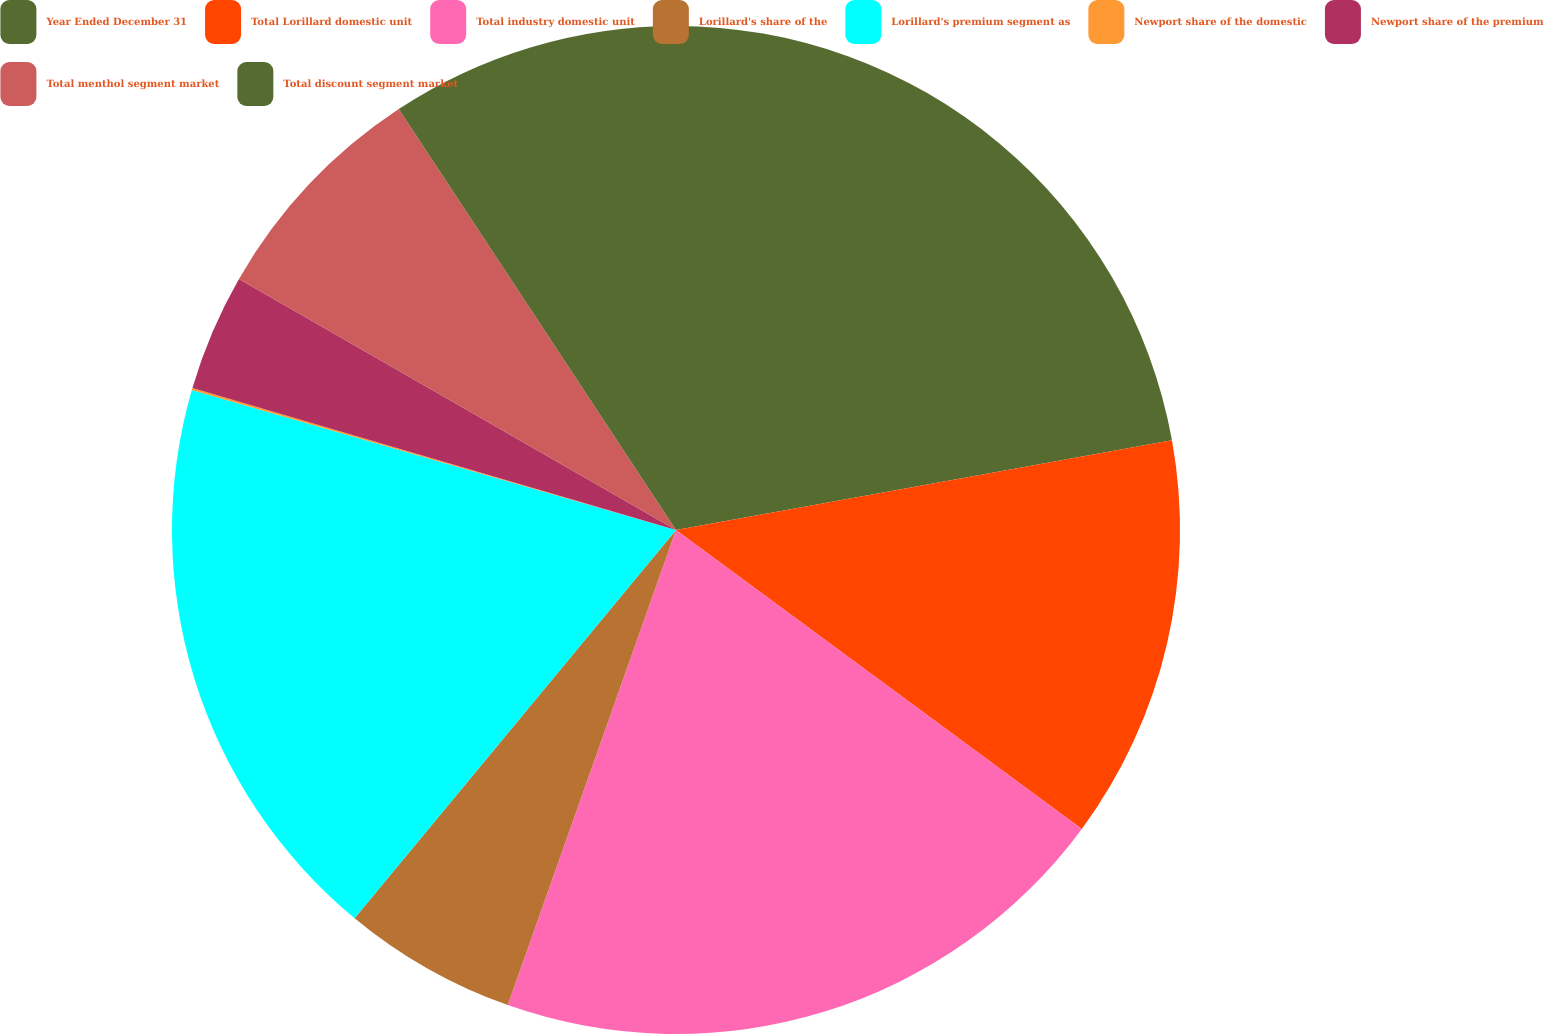<chart> <loc_0><loc_0><loc_500><loc_500><pie_chart><fcel>Year Ended December 31<fcel>Total Lorillard domestic unit<fcel>Total industry domestic unit<fcel>Lorillard's share of the<fcel>Lorillard's premium segment as<fcel>Newport share of the domestic<fcel>Newport share of the premium<fcel>Total menthol segment market<fcel>Total discount segment market<nl><fcel>22.15%<fcel>12.95%<fcel>20.31%<fcel>5.59%<fcel>18.47%<fcel>0.07%<fcel>3.75%<fcel>7.43%<fcel>9.27%<nl></chart> 